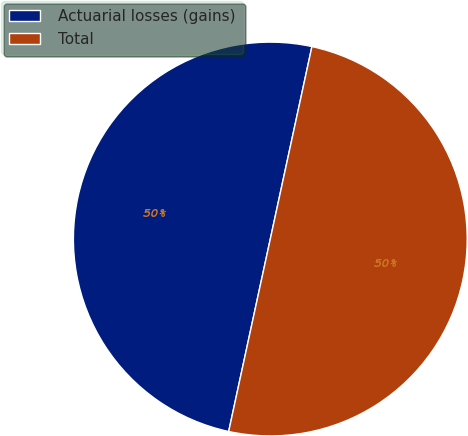Convert chart to OTSL. <chart><loc_0><loc_0><loc_500><loc_500><pie_chart><fcel>Actuarial losses (gains)<fcel>Total<nl><fcel>50.0%<fcel>50.0%<nl></chart> 